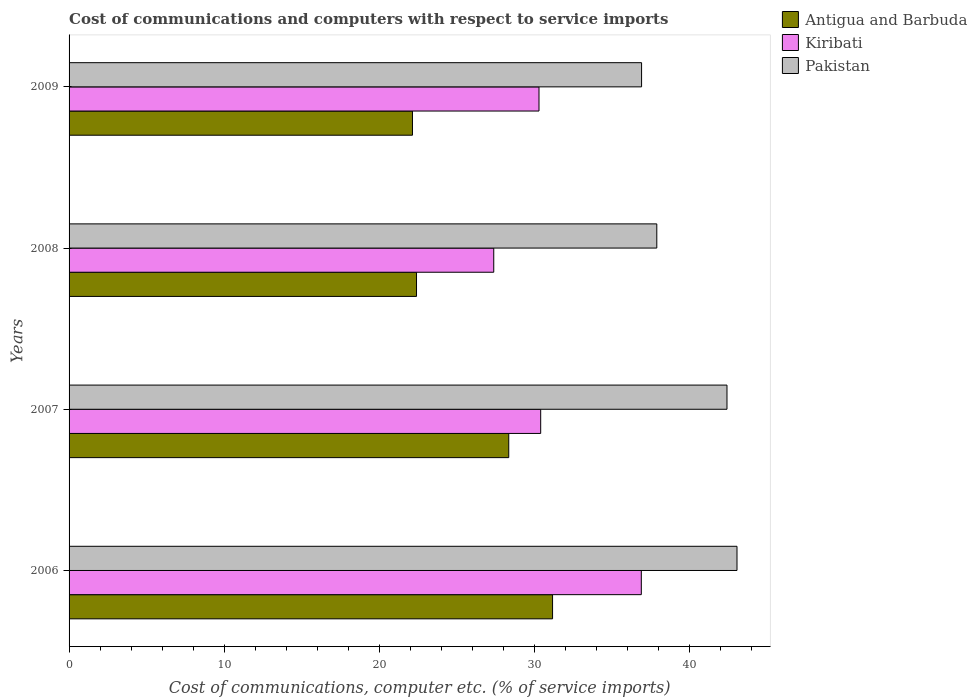What is the label of the 3rd group of bars from the top?
Your response must be concise. 2007. What is the cost of communications and computers in Pakistan in 2008?
Your answer should be very brief. 37.89. Across all years, what is the maximum cost of communications and computers in Kiribati?
Keep it short and to the point. 36.89. Across all years, what is the minimum cost of communications and computers in Kiribati?
Your answer should be compact. 27.38. In which year was the cost of communications and computers in Kiribati minimum?
Provide a short and direct response. 2008. What is the total cost of communications and computers in Antigua and Barbuda in the graph?
Your response must be concise. 104.04. What is the difference between the cost of communications and computers in Antigua and Barbuda in 2007 and that in 2009?
Provide a succinct answer. 6.21. What is the difference between the cost of communications and computers in Kiribati in 2009 and the cost of communications and computers in Pakistan in 2008?
Provide a succinct answer. -7.59. What is the average cost of communications and computers in Kiribati per year?
Offer a very short reply. 31.24. In the year 2009, what is the difference between the cost of communications and computers in Pakistan and cost of communications and computers in Antigua and Barbuda?
Give a very brief answer. 14.77. What is the ratio of the cost of communications and computers in Antigua and Barbuda in 2007 to that in 2008?
Offer a very short reply. 1.27. Is the difference between the cost of communications and computers in Pakistan in 2006 and 2007 greater than the difference between the cost of communications and computers in Antigua and Barbuda in 2006 and 2007?
Give a very brief answer. No. What is the difference between the highest and the second highest cost of communications and computers in Antigua and Barbuda?
Provide a short and direct response. 2.82. What is the difference between the highest and the lowest cost of communications and computers in Kiribati?
Give a very brief answer. 9.51. In how many years, is the cost of communications and computers in Kiribati greater than the average cost of communications and computers in Kiribati taken over all years?
Offer a terse response. 1. Is the sum of the cost of communications and computers in Pakistan in 2007 and 2008 greater than the maximum cost of communications and computers in Kiribati across all years?
Your answer should be compact. Yes. What does the 3rd bar from the top in 2007 represents?
Your response must be concise. Antigua and Barbuda. What does the 1st bar from the bottom in 2008 represents?
Offer a very short reply. Antigua and Barbuda. What is the difference between two consecutive major ticks on the X-axis?
Your answer should be compact. 10. How are the legend labels stacked?
Your answer should be very brief. Vertical. What is the title of the graph?
Provide a short and direct response. Cost of communications and computers with respect to service imports. What is the label or title of the X-axis?
Provide a succinct answer. Cost of communications, computer etc. (% of service imports). What is the label or title of the Y-axis?
Offer a terse response. Years. What is the Cost of communications, computer etc. (% of service imports) of Antigua and Barbuda in 2006?
Your response must be concise. 31.17. What is the Cost of communications, computer etc. (% of service imports) in Kiribati in 2006?
Your answer should be very brief. 36.89. What is the Cost of communications, computer etc. (% of service imports) in Pakistan in 2006?
Your answer should be very brief. 43.06. What is the Cost of communications, computer etc. (% of service imports) of Antigua and Barbuda in 2007?
Offer a terse response. 28.34. What is the Cost of communications, computer etc. (% of service imports) in Kiribati in 2007?
Offer a terse response. 30.4. What is the Cost of communications, computer etc. (% of service imports) of Pakistan in 2007?
Provide a short and direct response. 42.41. What is the Cost of communications, computer etc. (% of service imports) in Antigua and Barbuda in 2008?
Your response must be concise. 22.4. What is the Cost of communications, computer etc. (% of service imports) in Kiribati in 2008?
Offer a terse response. 27.38. What is the Cost of communications, computer etc. (% of service imports) of Pakistan in 2008?
Your response must be concise. 37.89. What is the Cost of communications, computer etc. (% of service imports) in Antigua and Barbuda in 2009?
Keep it short and to the point. 22.14. What is the Cost of communications, computer etc. (% of service imports) in Kiribati in 2009?
Your response must be concise. 30.29. What is the Cost of communications, computer etc. (% of service imports) of Pakistan in 2009?
Your answer should be very brief. 36.91. Across all years, what is the maximum Cost of communications, computer etc. (% of service imports) of Antigua and Barbuda?
Keep it short and to the point. 31.17. Across all years, what is the maximum Cost of communications, computer etc. (% of service imports) of Kiribati?
Ensure brevity in your answer.  36.89. Across all years, what is the maximum Cost of communications, computer etc. (% of service imports) of Pakistan?
Provide a succinct answer. 43.06. Across all years, what is the minimum Cost of communications, computer etc. (% of service imports) in Antigua and Barbuda?
Your answer should be compact. 22.14. Across all years, what is the minimum Cost of communications, computer etc. (% of service imports) in Kiribati?
Provide a succinct answer. 27.38. Across all years, what is the minimum Cost of communications, computer etc. (% of service imports) in Pakistan?
Offer a very short reply. 36.91. What is the total Cost of communications, computer etc. (% of service imports) of Antigua and Barbuda in the graph?
Give a very brief answer. 104.04. What is the total Cost of communications, computer etc. (% of service imports) of Kiribati in the graph?
Your answer should be very brief. 124.96. What is the total Cost of communications, computer etc. (% of service imports) in Pakistan in the graph?
Offer a very short reply. 160.26. What is the difference between the Cost of communications, computer etc. (% of service imports) of Antigua and Barbuda in 2006 and that in 2007?
Provide a short and direct response. 2.82. What is the difference between the Cost of communications, computer etc. (% of service imports) in Kiribati in 2006 and that in 2007?
Make the answer very short. 6.49. What is the difference between the Cost of communications, computer etc. (% of service imports) of Pakistan in 2006 and that in 2007?
Your answer should be compact. 0.65. What is the difference between the Cost of communications, computer etc. (% of service imports) in Antigua and Barbuda in 2006 and that in 2008?
Your answer should be very brief. 8.77. What is the difference between the Cost of communications, computer etc. (% of service imports) in Kiribati in 2006 and that in 2008?
Provide a short and direct response. 9.51. What is the difference between the Cost of communications, computer etc. (% of service imports) of Pakistan in 2006 and that in 2008?
Offer a terse response. 5.17. What is the difference between the Cost of communications, computer etc. (% of service imports) of Antigua and Barbuda in 2006 and that in 2009?
Provide a succinct answer. 9.03. What is the difference between the Cost of communications, computer etc. (% of service imports) of Kiribati in 2006 and that in 2009?
Give a very brief answer. 6.6. What is the difference between the Cost of communications, computer etc. (% of service imports) of Pakistan in 2006 and that in 2009?
Offer a very short reply. 6.15. What is the difference between the Cost of communications, computer etc. (% of service imports) in Antigua and Barbuda in 2007 and that in 2008?
Ensure brevity in your answer.  5.95. What is the difference between the Cost of communications, computer etc. (% of service imports) of Kiribati in 2007 and that in 2008?
Ensure brevity in your answer.  3.03. What is the difference between the Cost of communications, computer etc. (% of service imports) in Pakistan in 2007 and that in 2008?
Make the answer very short. 4.52. What is the difference between the Cost of communications, computer etc. (% of service imports) in Antigua and Barbuda in 2007 and that in 2009?
Your answer should be very brief. 6.21. What is the difference between the Cost of communications, computer etc. (% of service imports) of Kiribati in 2007 and that in 2009?
Your answer should be very brief. 0.11. What is the difference between the Cost of communications, computer etc. (% of service imports) of Pakistan in 2007 and that in 2009?
Make the answer very short. 5.51. What is the difference between the Cost of communications, computer etc. (% of service imports) of Antigua and Barbuda in 2008 and that in 2009?
Ensure brevity in your answer.  0.26. What is the difference between the Cost of communications, computer etc. (% of service imports) of Kiribati in 2008 and that in 2009?
Your response must be concise. -2.92. What is the difference between the Cost of communications, computer etc. (% of service imports) in Pakistan in 2008 and that in 2009?
Provide a short and direct response. 0.98. What is the difference between the Cost of communications, computer etc. (% of service imports) of Antigua and Barbuda in 2006 and the Cost of communications, computer etc. (% of service imports) of Kiribati in 2007?
Offer a terse response. 0.77. What is the difference between the Cost of communications, computer etc. (% of service imports) in Antigua and Barbuda in 2006 and the Cost of communications, computer etc. (% of service imports) in Pakistan in 2007?
Provide a short and direct response. -11.24. What is the difference between the Cost of communications, computer etc. (% of service imports) of Kiribati in 2006 and the Cost of communications, computer etc. (% of service imports) of Pakistan in 2007?
Your response must be concise. -5.52. What is the difference between the Cost of communications, computer etc. (% of service imports) in Antigua and Barbuda in 2006 and the Cost of communications, computer etc. (% of service imports) in Kiribati in 2008?
Offer a terse response. 3.79. What is the difference between the Cost of communications, computer etc. (% of service imports) of Antigua and Barbuda in 2006 and the Cost of communications, computer etc. (% of service imports) of Pakistan in 2008?
Keep it short and to the point. -6.72. What is the difference between the Cost of communications, computer etc. (% of service imports) in Kiribati in 2006 and the Cost of communications, computer etc. (% of service imports) in Pakistan in 2008?
Offer a very short reply. -1. What is the difference between the Cost of communications, computer etc. (% of service imports) of Antigua and Barbuda in 2006 and the Cost of communications, computer etc. (% of service imports) of Kiribati in 2009?
Your answer should be very brief. 0.87. What is the difference between the Cost of communications, computer etc. (% of service imports) of Antigua and Barbuda in 2006 and the Cost of communications, computer etc. (% of service imports) of Pakistan in 2009?
Your answer should be very brief. -5.74. What is the difference between the Cost of communications, computer etc. (% of service imports) in Kiribati in 2006 and the Cost of communications, computer etc. (% of service imports) in Pakistan in 2009?
Give a very brief answer. -0.02. What is the difference between the Cost of communications, computer etc. (% of service imports) of Antigua and Barbuda in 2007 and the Cost of communications, computer etc. (% of service imports) of Kiribati in 2008?
Offer a very short reply. 0.97. What is the difference between the Cost of communications, computer etc. (% of service imports) in Antigua and Barbuda in 2007 and the Cost of communications, computer etc. (% of service imports) in Pakistan in 2008?
Your answer should be compact. -9.54. What is the difference between the Cost of communications, computer etc. (% of service imports) in Kiribati in 2007 and the Cost of communications, computer etc. (% of service imports) in Pakistan in 2008?
Keep it short and to the point. -7.49. What is the difference between the Cost of communications, computer etc. (% of service imports) of Antigua and Barbuda in 2007 and the Cost of communications, computer etc. (% of service imports) of Kiribati in 2009?
Your response must be concise. -1.95. What is the difference between the Cost of communications, computer etc. (% of service imports) in Antigua and Barbuda in 2007 and the Cost of communications, computer etc. (% of service imports) in Pakistan in 2009?
Your answer should be very brief. -8.56. What is the difference between the Cost of communications, computer etc. (% of service imports) of Kiribati in 2007 and the Cost of communications, computer etc. (% of service imports) of Pakistan in 2009?
Your answer should be very brief. -6.5. What is the difference between the Cost of communications, computer etc. (% of service imports) in Antigua and Barbuda in 2008 and the Cost of communications, computer etc. (% of service imports) in Kiribati in 2009?
Your answer should be very brief. -7.9. What is the difference between the Cost of communications, computer etc. (% of service imports) in Antigua and Barbuda in 2008 and the Cost of communications, computer etc. (% of service imports) in Pakistan in 2009?
Keep it short and to the point. -14.51. What is the difference between the Cost of communications, computer etc. (% of service imports) of Kiribati in 2008 and the Cost of communications, computer etc. (% of service imports) of Pakistan in 2009?
Provide a short and direct response. -9.53. What is the average Cost of communications, computer etc. (% of service imports) of Antigua and Barbuda per year?
Offer a terse response. 26.01. What is the average Cost of communications, computer etc. (% of service imports) of Kiribati per year?
Your response must be concise. 31.24. What is the average Cost of communications, computer etc. (% of service imports) of Pakistan per year?
Your response must be concise. 40.07. In the year 2006, what is the difference between the Cost of communications, computer etc. (% of service imports) in Antigua and Barbuda and Cost of communications, computer etc. (% of service imports) in Kiribati?
Your answer should be very brief. -5.72. In the year 2006, what is the difference between the Cost of communications, computer etc. (% of service imports) of Antigua and Barbuda and Cost of communications, computer etc. (% of service imports) of Pakistan?
Provide a succinct answer. -11.89. In the year 2006, what is the difference between the Cost of communications, computer etc. (% of service imports) of Kiribati and Cost of communications, computer etc. (% of service imports) of Pakistan?
Provide a succinct answer. -6.17. In the year 2007, what is the difference between the Cost of communications, computer etc. (% of service imports) of Antigua and Barbuda and Cost of communications, computer etc. (% of service imports) of Kiribati?
Provide a succinct answer. -2.06. In the year 2007, what is the difference between the Cost of communications, computer etc. (% of service imports) in Antigua and Barbuda and Cost of communications, computer etc. (% of service imports) in Pakistan?
Your answer should be very brief. -14.07. In the year 2007, what is the difference between the Cost of communications, computer etc. (% of service imports) in Kiribati and Cost of communications, computer etc. (% of service imports) in Pakistan?
Offer a very short reply. -12.01. In the year 2008, what is the difference between the Cost of communications, computer etc. (% of service imports) in Antigua and Barbuda and Cost of communications, computer etc. (% of service imports) in Kiribati?
Give a very brief answer. -4.98. In the year 2008, what is the difference between the Cost of communications, computer etc. (% of service imports) of Antigua and Barbuda and Cost of communications, computer etc. (% of service imports) of Pakistan?
Provide a succinct answer. -15.49. In the year 2008, what is the difference between the Cost of communications, computer etc. (% of service imports) of Kiribati and Cost of communications, computer etc. (% of service imports) of Pakistan?
Make the answer very short. -10.51. In the year 2009, what is the difference between the Cost of communications, computer etc. (% of service imports) in Antigua and Barbuda and Cost of communications, computer etc. (% of service imports) in Kiribati?
Provide a short and direct response. -8.16. In the year 2009, what is the difference between the Cost of communications, computer etc. (% of service imports) of Antigua and Barbuda and Cost of communications, computer etc. (% of service imports) of Pakistan?
Give a very brief answer. -14.77. In the year 2009, what is the difference between the Cost of communications, computer etc. (% of service imports) of Kiribati and Cost of communications, computer etc. (% of service imports) of Pakistan?
Keep it short and to the point. -6.61. What is the ratio of the Cost of communications, computer etc. (% of service imports) in Antigua and Barbuda in 2006 to that in 2007?
Offer a terse response. 1.1. What is the ratio of the Cost of communications, computer etc. (% of service imports) of Kiribati in 2006 to that in 2007?
Provide a short and direct response. 1.21. What is the ratio of the Cost of communications, computer etc. (% of service imports) in Pakistan in 2006 to that in 2007?
Your answer should be compact. 1.02. What is the ratio of the Cost of communications, computer etc. (% of service imports) in Antigua and Barbuda in 2006 to that in 2008?
Give a very brief answer. 1.39. What is the ratio of the Cost of communications, computer etc. (% of service imports) in Kiribati in 2006 to that in 2008?
Make the answer very short. 1.35. What is the ratio of the Cost of communications, computer etc. (% of service imports) in Pakistan in 2006 to that in 2008?
Offer a very short reply. 1.14. What is the ratio of the Cost of communications, computer etc. (% of service imports) of Antigua and Barbuda in 2006 to that in 2009?
Offer a terse response. 1.41. What is the ratio of the Cost of communications, computer etc. (% of service imports) in Kiribati in 2006 to that in 2009?
Your response must be concise. 1.22. What is the ratio of the Cost of communications, computer etc. (% of service imports) of Pakistan in 2006 to that in 2009?
Make the answer very short. 1.17. What is the ratio of the Cost of communications, computer etc. (% of service imports) in Antigua and Barbuda in 2007 to that in 2008?
Offer a very short reply. 1.27. What is the ratio of the Cost of communications, computer etc. (% of service imports) in Kiribati in 2007 to that in 2008?
Make the answer very short. 1.11. What is the ratio of the Cost of communications, computer etc. (% of service imports) in Pakistan in 2007 to that in 2008?
Your answer should be very brief. 1.12. What is the ratio of the Cost of communications, computer etc. (% of service imports) of Antigua and Barbuda in 2007 to that in 2009?
Keep it short and to the point. 1.28. What is the ratio of the Cost of communications, computer etc. (% of service imports) of Pakistan in 2007 to that in 2009?
Keep it short and to the point. 1.15. What is the ratio of the Cost of communications, computer etc. (% of service imports) of Antigua and Barbuda in 2008 to that in 2009?
Provide a succinct answer. 1.01. What is the ratio of the Cost of communications, computer etc. (% of service imports) of Kiribati in 2008 to that in 2009?
Provide a short and direct response. 0.9. What is the ratio of the Cost of communications, computer etc. (% of service imports) of Pakistan in 2008 to that in 2009?
Give a very brief answer. 1.03. What is the difference between the highest and the second highest Cost of communications, computer etc. (% of service imports) in Antigua and Barbuda?
Offer a terse response. 2.82. What is the difference between the highest and the second highest Cost of communications, computer etc. (% of service imports) in Kiribati?
Give a very brief answer. 6.49. What is the difference between the highest and the second highest Cost of communications, computer etc. (% of service imports) in Pakistan?
Your answer should be very brief. 0.65. What is the difference between the highest and the lowest Cost of communications, computer etc. (% of service imports) of Antigua and Barbuda?
Your answer should be compact. 9.03. What is the difference between the highest and the lowest Cost of communications, computer etc. (% of service imports) of Kiribati?
Give a very brief answer. 9.51. What is the difference between the highest and the lowest Cost of communications, computer etc. (% of service imports) of Pakistan?
Ensure brevity in your answer.  6.15. 